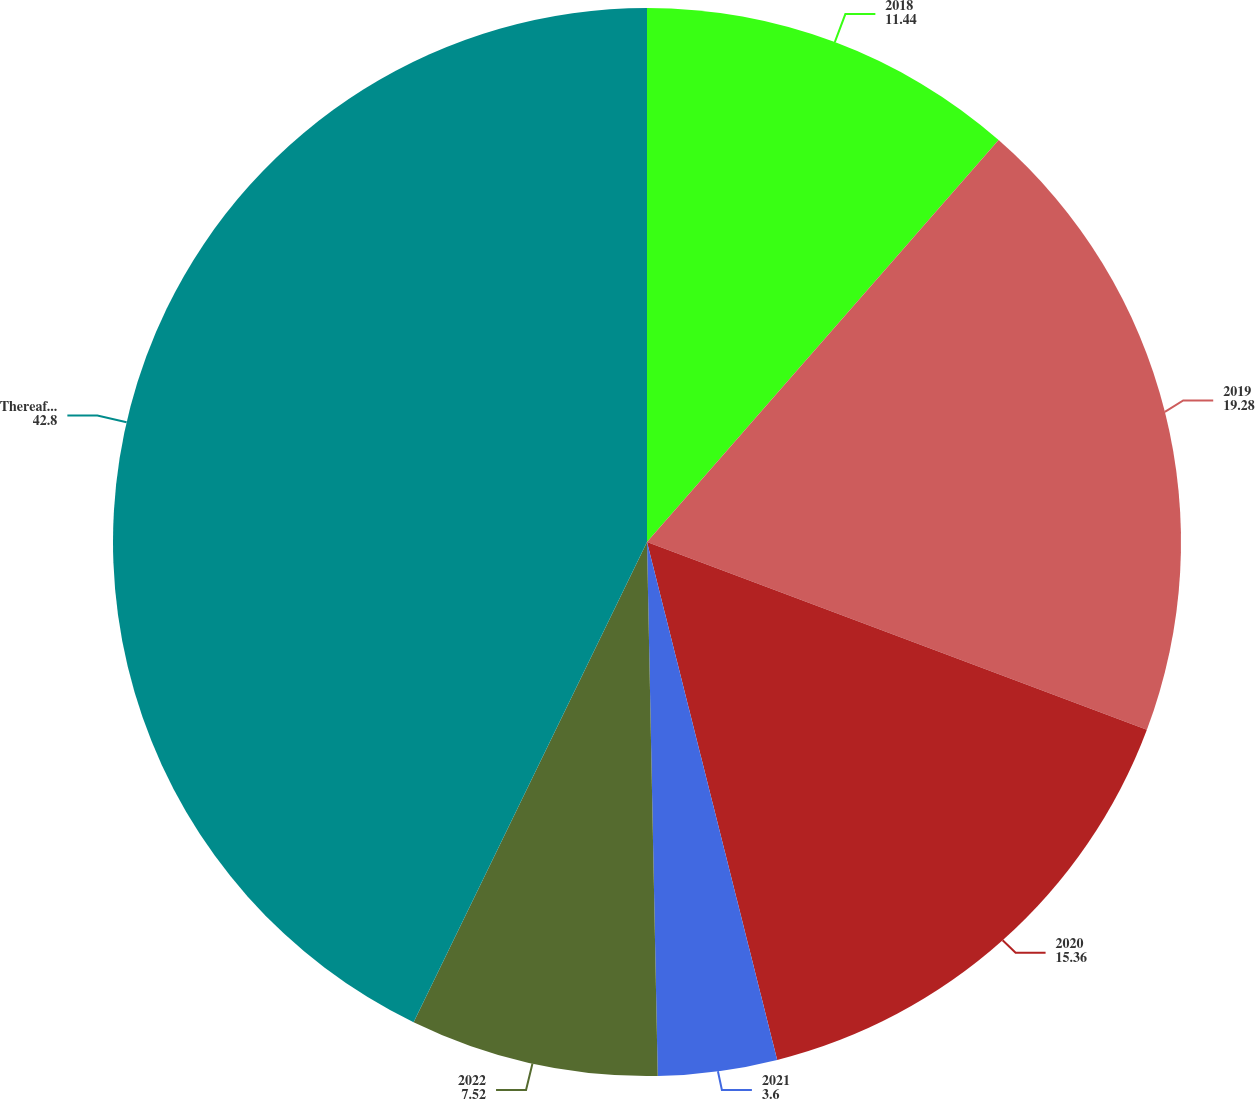<chart> <loc_0><loc_0><loc_500><loc_500><pie_chart><fcel>2018<fcel>2019<fcel>2020<fcel>2021<fcel>2022<fcel>Thereafter<nl><fcel>11.44%<fcel>19.28%<fcel>15.36%<fcel>3.6%<fcel>7.52%<fcel>42.8%<nl></chart> 